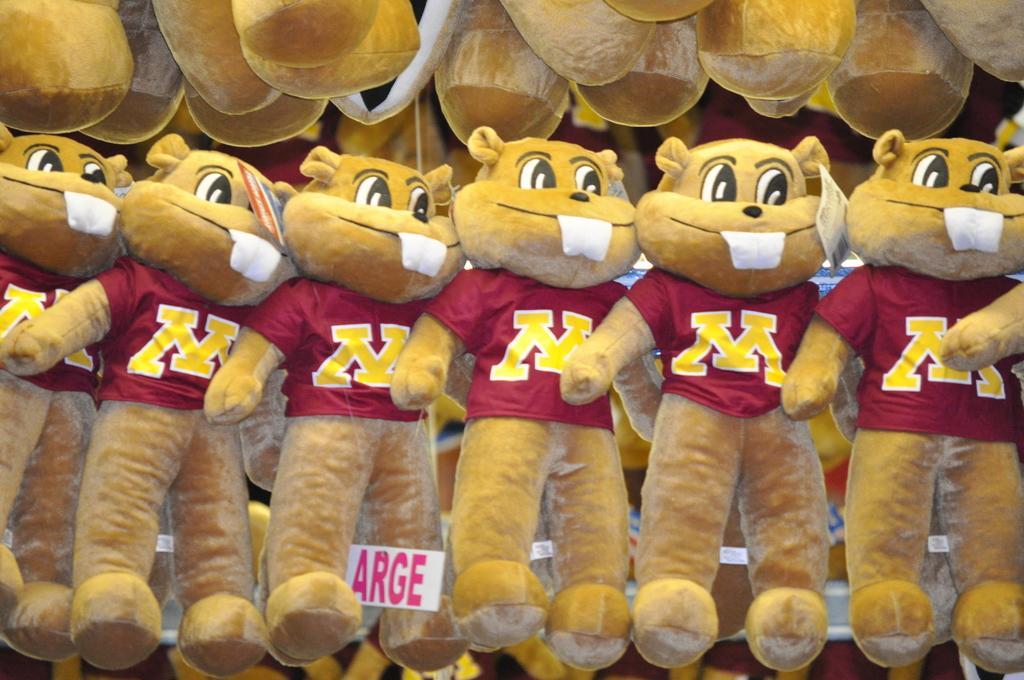How would you summarize this image in a sentence or two? Here in this picture we can see teddy bears hanging over the place over there. 